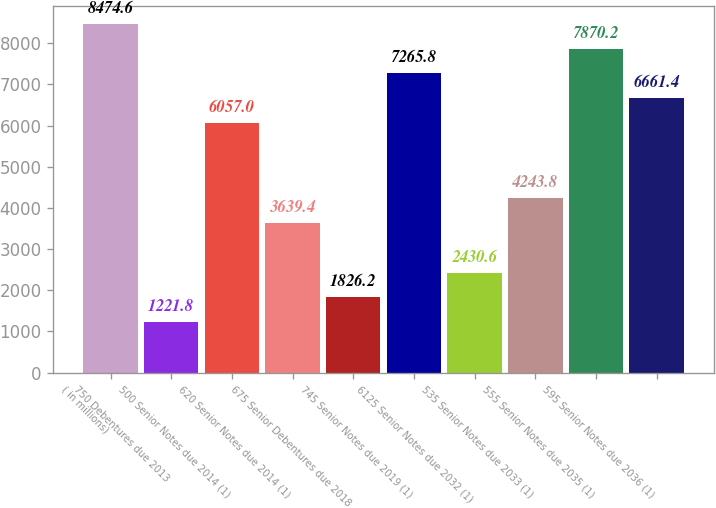<chart> <loc_0><loc_0><loc_500><loc_500><bar_chart><fcel>( in millions)<fcel>750 Debentures due 2013<fcel>500 Senior Notes due 2014 (1)<fcel>620 Senior Notes due 2014 (1)<fcel>675 Senior Debentures due 2018<fcel>745 Senior Notes due 2019 (1)<fcel>6125 Senior Notes due 2032 (1)<fcel>535 Senior Notes due 2033 (1)<fcel>555 Senior Notes due 2035 (1)<fcel>595 Senior Notes due 2036 (1)<nl><fcel>8474.6<fcel>1221.8<fcel>6057<fcel>3639.4<fcel>1826.2<fcel>7265.8<fcel>2430.6<fcel>4243.8<fcel>7870.2<fcel>6661.4<nl></chart> 